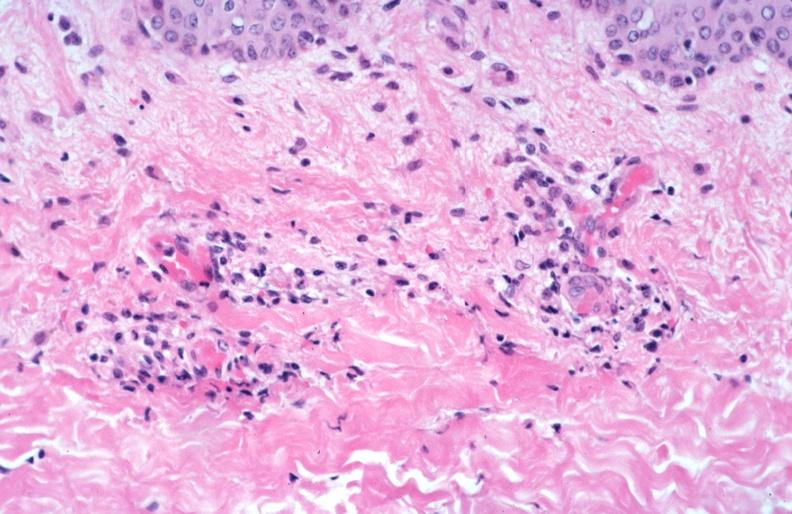what is rocky mountain spotted?
Answer the question using a single word or phrase. Fever 